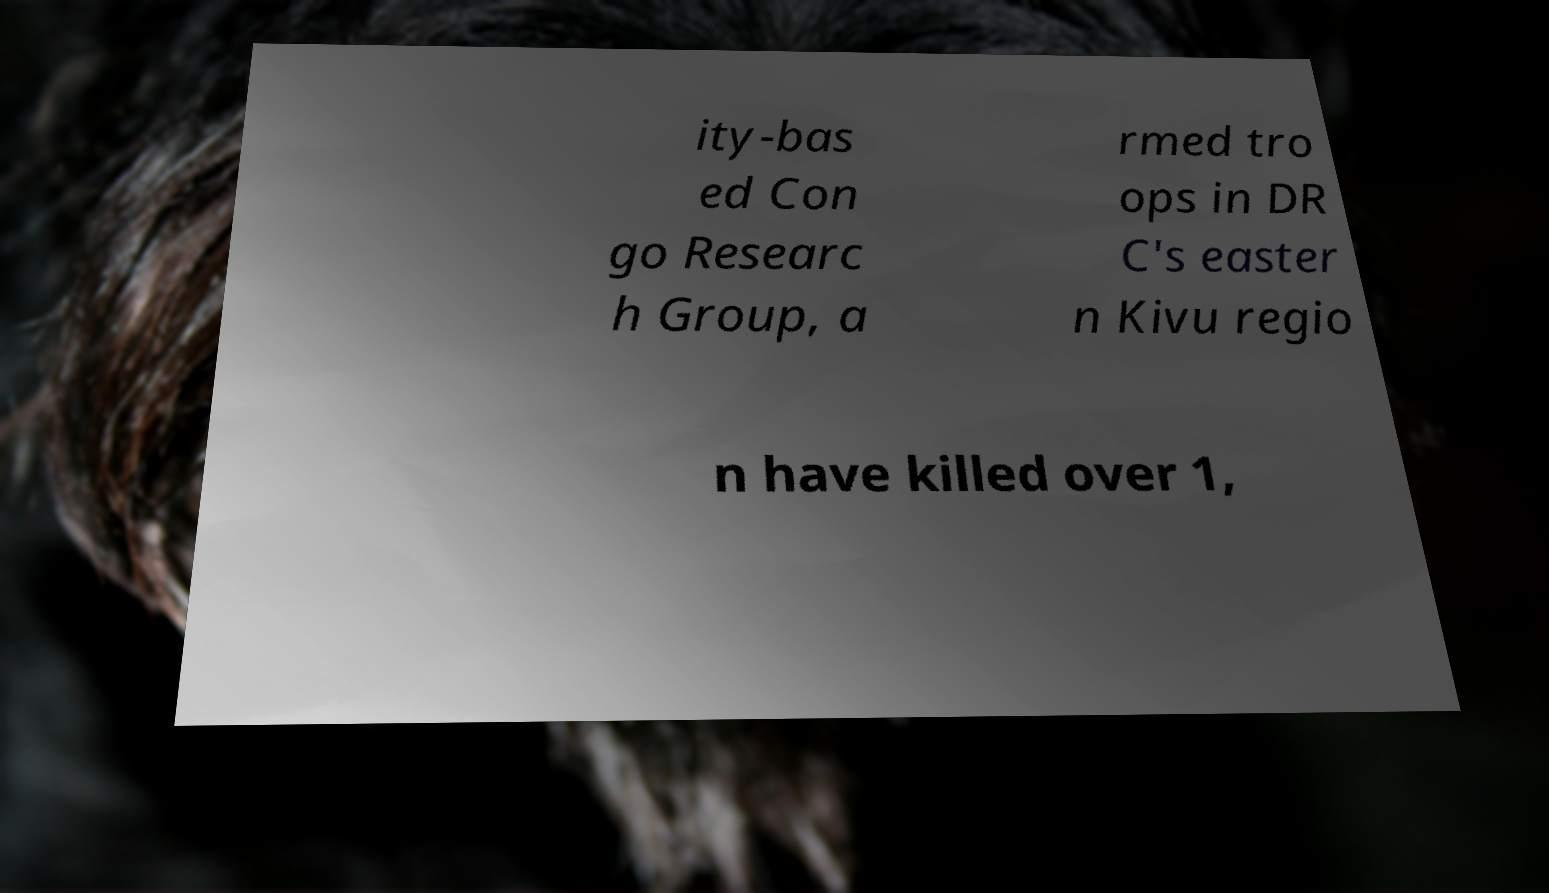Can you accurately transcribe the text from the provided image for me? ity-bas ed Con go Researc h Group, a rmed tro ops in DR C's easter n Kivu regio n have killed over 1, 